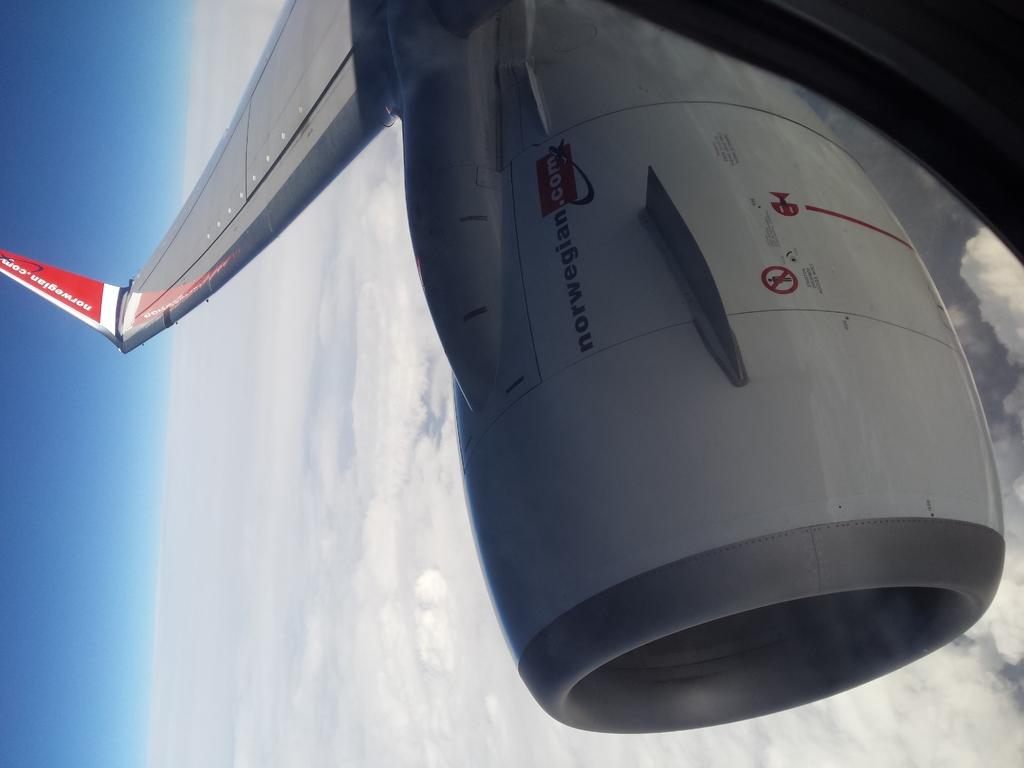What is the website shown?
Offer a very short reply. Norwegian.com. What is written on this airplane?
Offer a very short reply. Norwegian.com. 